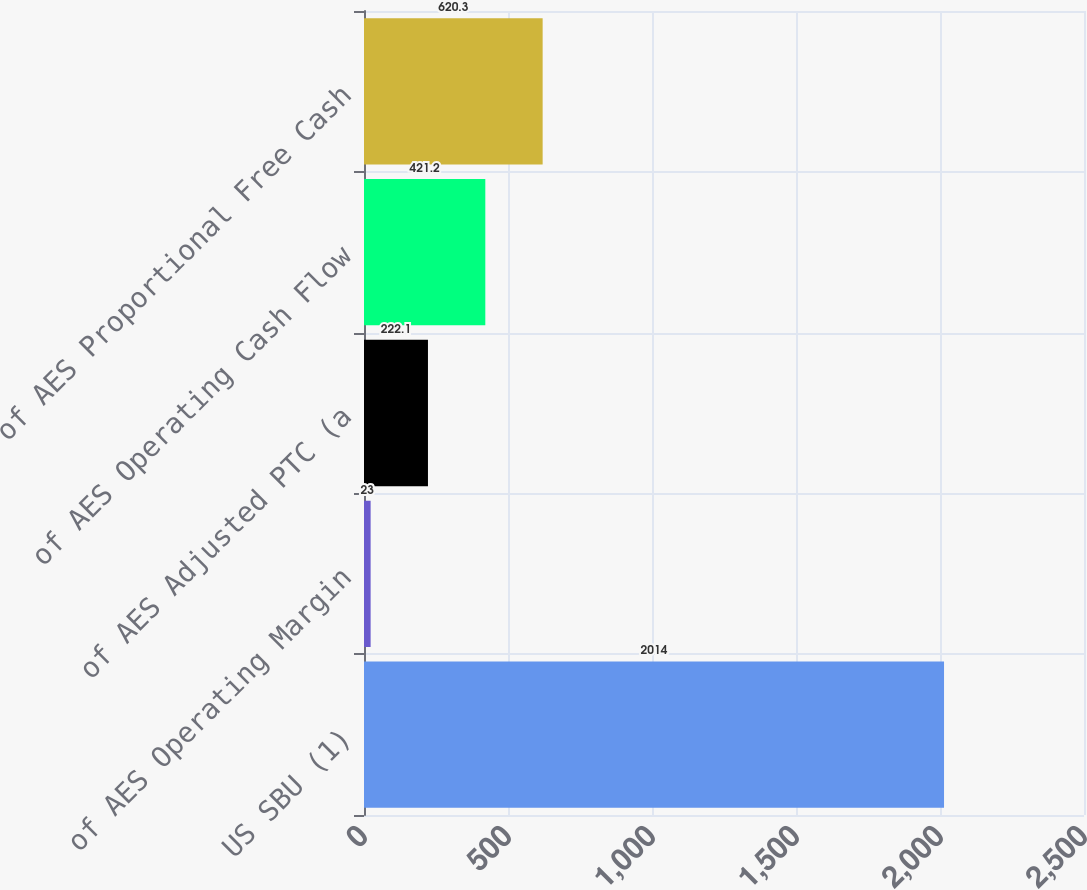Convert chart. <chart><loc_0><loc_0><loc_500><loc_500><bar_chart><fcel>US SBU (1)<fcel>of AES Operating Margin<fcel>of AES Adjusted PTC (a<fcel>of AES Operating Cash Flow<fcel>of AES Proportional Free Cash<nl><fcel>2014<fcel>23<fcel>222.1<fcel>421.2<fcel>620.3<nl></chart> 